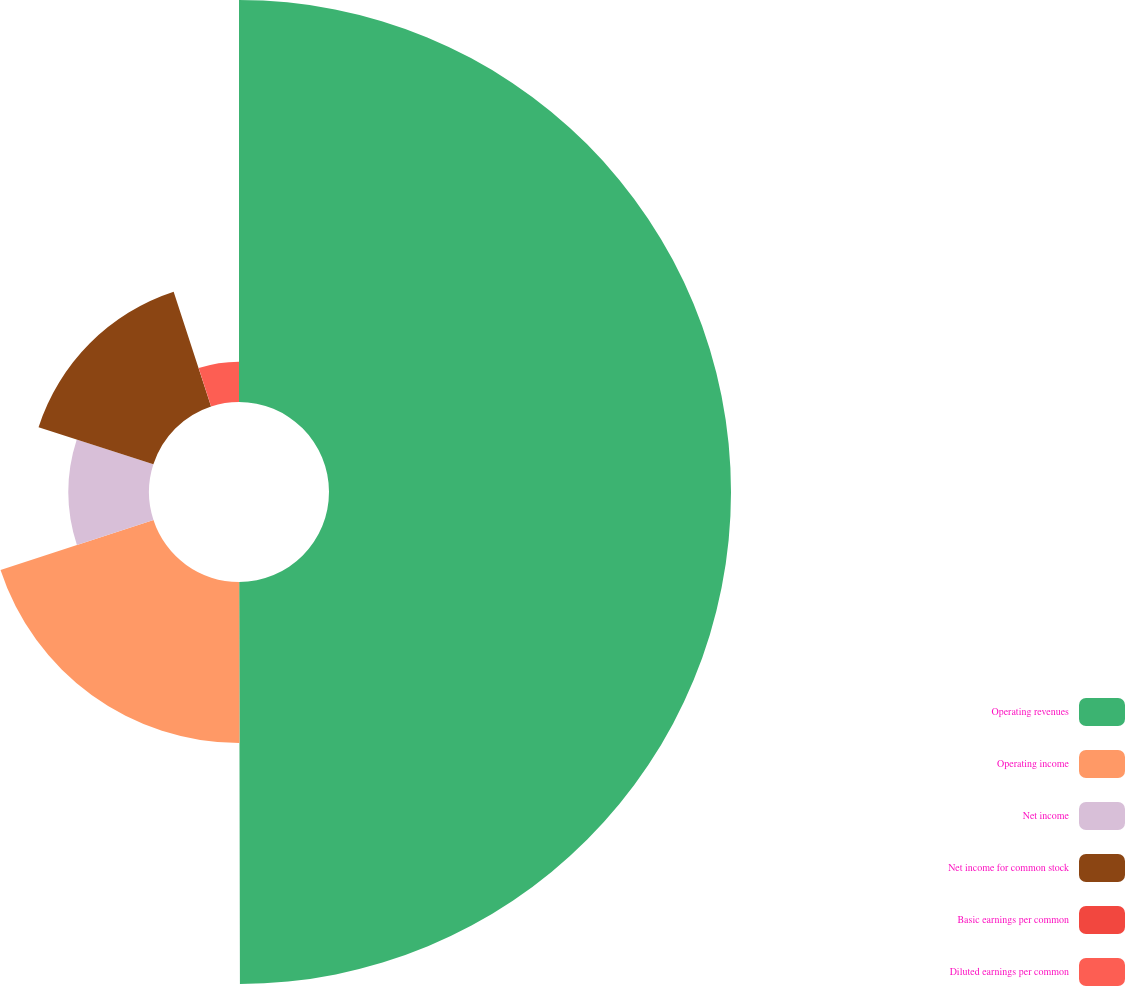Convert chart. <chart><loc_0><loc_0><loc_500><loc_500><pie_chart><fcel>Operating revenues<fcel>Operating income<fcel>Net income<fcel>Net income for common stock<fcel>Basic earnings per common<fcel>Diluted earnings per common<nl><fcel>49.97%<fcel>20.0%<fcel>10.01%<fcel>15.0%<fcel>0.01%<fcel>5.01%<nl></chart> 